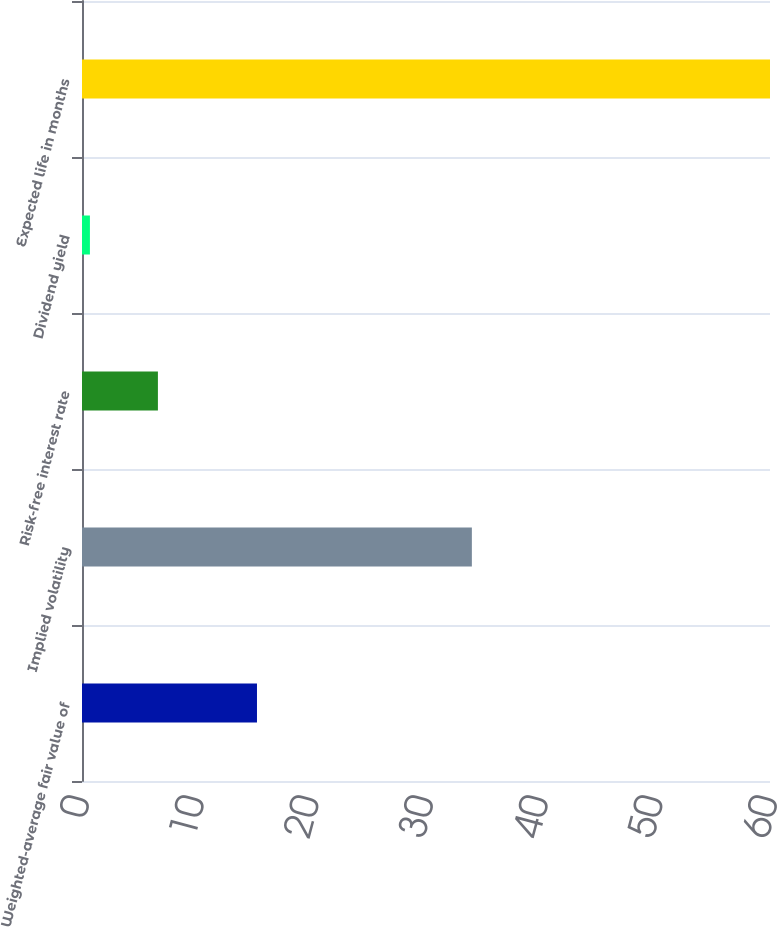<chart> <loc_0><loc_0><loc_500><loc_500><bar_chart><fcel>Weighted-average fair value of<fcel>Implied volatility<fcel>Risk-free interest rate<fcel>Dividend yield<fcel>Expected life in months<nl><fcel>15.26<fcel>34<fcel>6.62<fcel>0.69<fcel>60<nl></chart> 